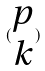Convert formula to latex. <formula><loc_0><loc_0><loc_500><loc_500>( \begin{matrix} p \\ k \end{matrix} )</formula> 